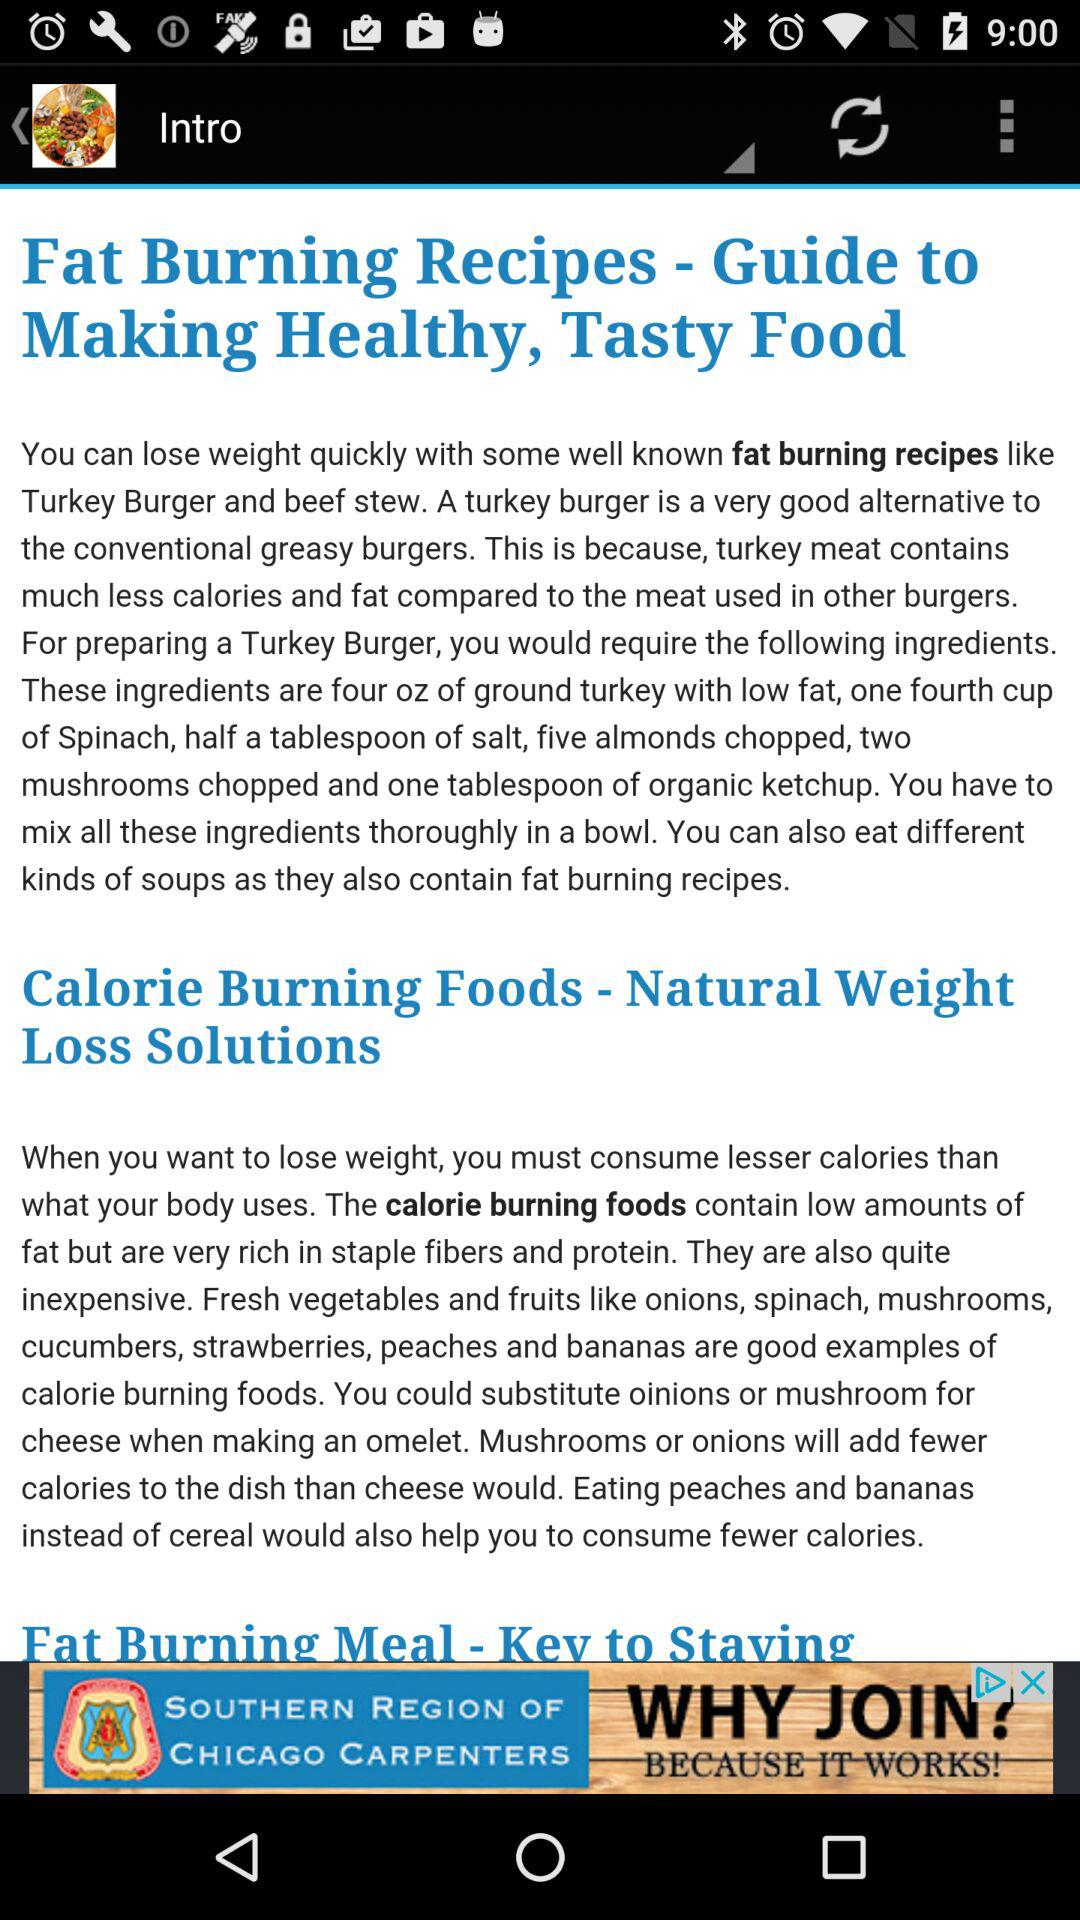How many fat-burning recipes are there?
When the provided information is insufficient, respond with <no answer>. <no answer> 